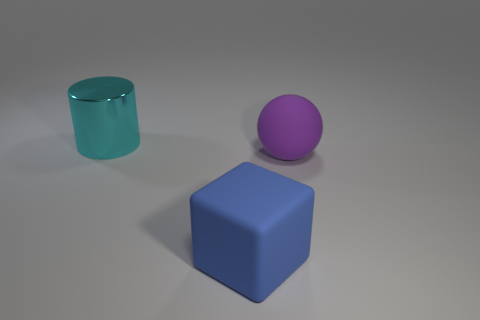Add 1 large gray matte cylinders. How many objects exist? 4 Subtract all balls. How many objects are left? 2 Subtract 1 blue cubes. How many objects are left? 2 Subtract all large blue objects. Subtract all large purple objects. How many objects are left? 1 Add 2 rubber spheres. How many rubber spheres are left? 3 Add 2 green metal cylinders. How many green metal cylinders exist? 2 